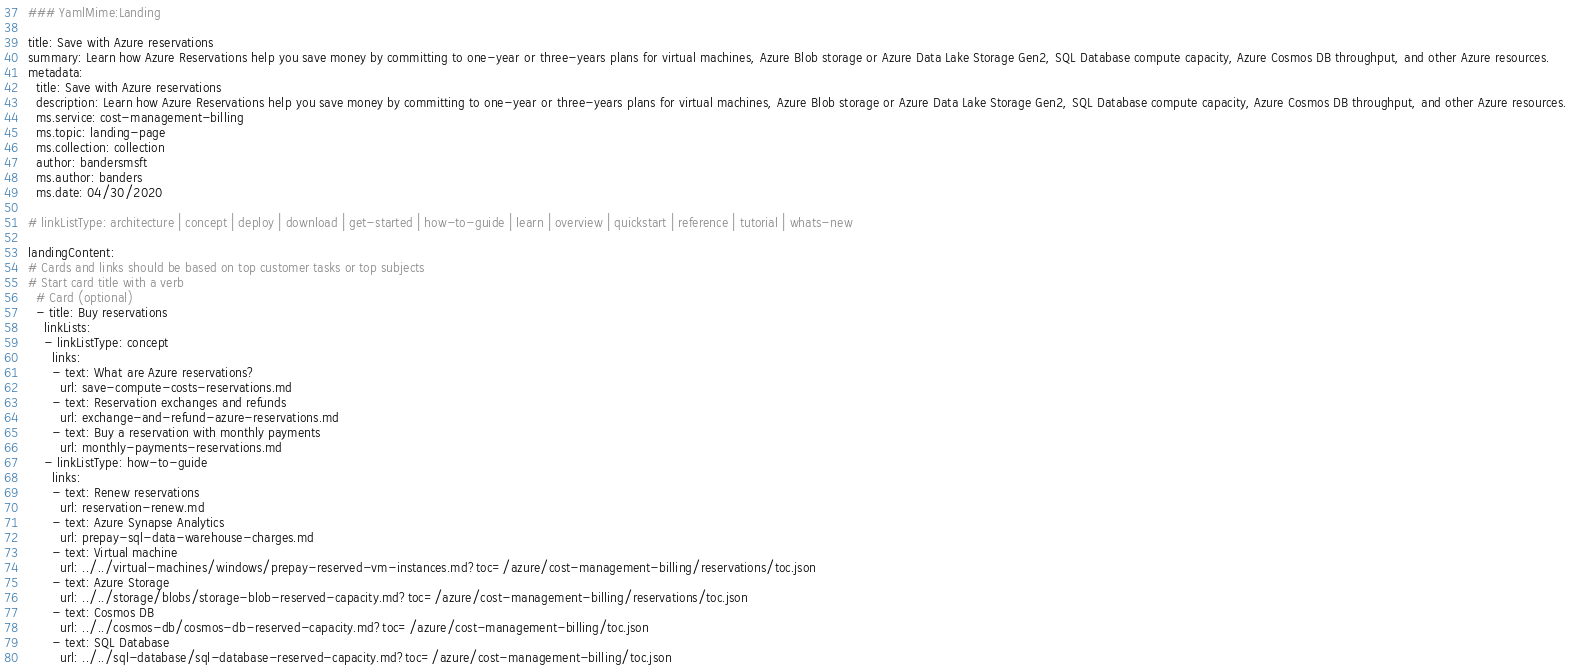Convert code to text. <code><loc_0><loc_0><loc_500><loc_500><_YAML_>### YamlMime:Landing

title: Save with Azure reservations
summary: Learn how Azure Reservations help you save money by committing to one-year or three-years plans for virtual machines, Azure Blob storage or Azure Data Lake Storage Gen2, SQL Database compute capacity, Azure Cosmos DB throughput, and other Azure resources. 
metadata:
  title: Save with Azure reservations
  description: Learn how Azure Reservations help you save money by committing to one-year or three-years plans for virtual machines, Azure Blob storage or Azure Data Lake Storage Gen2, SQL Database compute capacity, Azure Cosmos DB throughput, and other Azure resources. 
  ms.service: cost-management-billing
  ms.topic: landing-page
  ms.collection: collection
  author: bandersmsft
  ms.author: banders
  ms.date: 04/30/2020

# linkListType: architecture | concept | deploy | download | get-started | how-to-guide | learn | overview | quickstart | reference | tutorial | whats-new

landingContent:
# Cards and links should be based on top customer tasks or top subjects
# Start card title with a verb
  # Card (optional)
  - title: Buy reservations
    linkLists:
    - linkListType: concept
      links:
      - text: What are Azure reservations?
        url: save-compute-costs-reservations.md
      - text: Reservation exchanges and refunds
        url: exchange-and-refund-azure-reservations.md
      - text: Buy a reservation with monthly payments
        url: monthly-payments-reservations.md
    - linkListType: how-to-guide
      links:
      - text: Renew reservations
        url: reservation-renew.md
      - text: Azure Synapse Analytics
        url: prepay-sql-data-warehouse-charges.md
      - text: Virtual machine
        url: ../../virtual-machines/windows/prepay-reserved-vm-instances.md?toc=/azure/cost-management-billing/reservations/toc.json
      - text: Azure Storage
        url: ../../storage/blobs/storage-blob-reserved-capacity.md?toc=/azure/cost-management-billing/reservations/toc.json
      - text: Cosmos DB
        url: ../../cosmos-db/cosmos-db-reserved-capacity.md?toc=/azure/cost-management-billing/toc.json
      - text: SQL Database
        url: ../../sql-database/sql-database-reserved-capacity.md?toc=/azure/cost-management-billing/toc.json</code> 